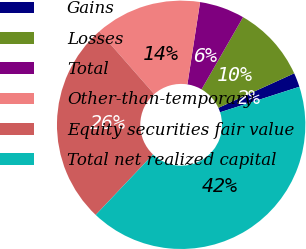<chart> <loc_0><loc_0><loc_500><loc_500><pie_chart><fcel>Gains<fcel>Losses<fcel>Total<fcel>Other-than-temporary<fcel>Equity securities fair value<fcel>Total net realized capital<nl><fcel>1.85%<fcel>9.89%<fcel>5.87%<fcel>13.9%<fcel>26.46%<fcel>42.03%<nl></chart> 